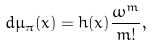Convert formula to latex. <formula><loc_0><loc_0><loc_500><loc_500>d \mu _ { \pi } ( x ) = h ( x ) \frac { \omega ^ { m } } { m ! } ,</formula> 